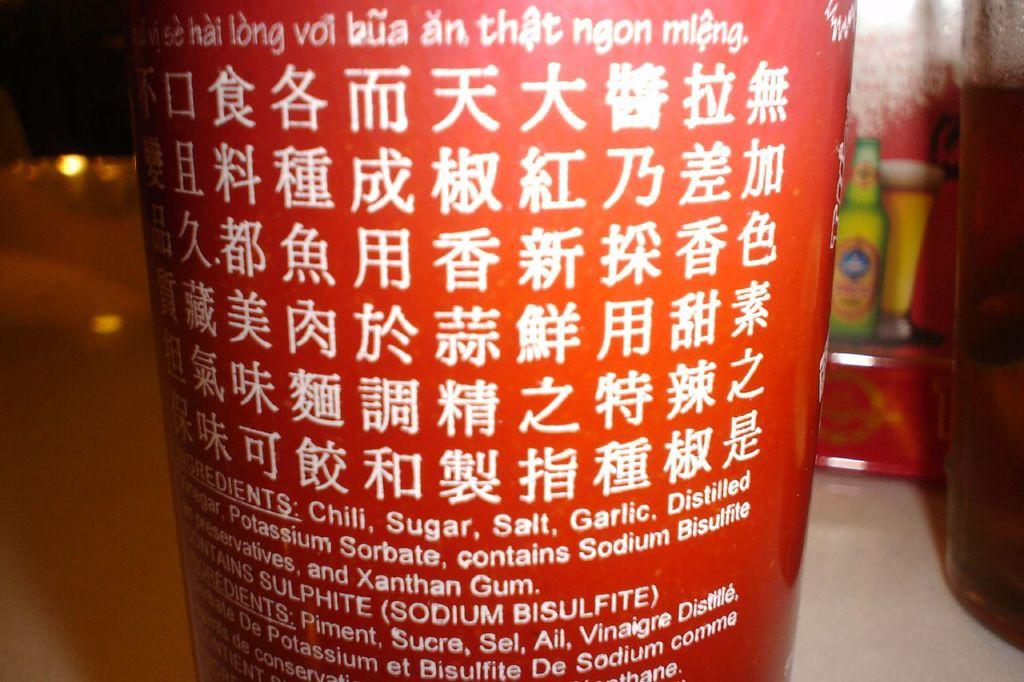Provide a one-sentence caption for the provided image. A jar or bottle lists the ingredients that include chili, sugar, salt, garlic and sodium bisulfite. 